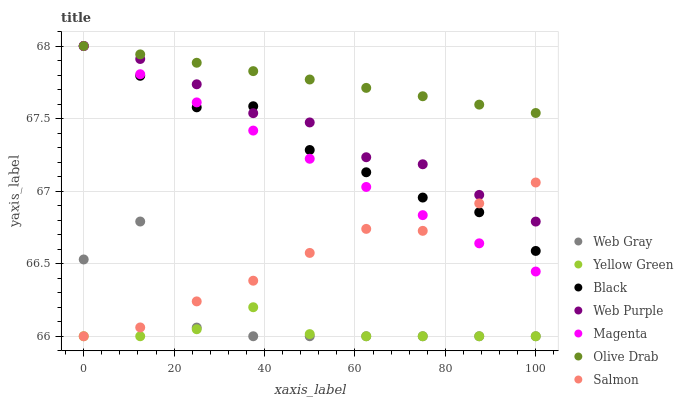Does Yellow Green have the minimum area under the curve?
Answer yes or no. Yes. Does Olive Drab have the maximum area under the curve?
Answer yes or no. Yes. Does Salmon have the minimum area under the curve?
Answer yes or no. No. Does Salmon have the maximum area under the curve?
Answer yes or no. No. Is Olive Drab the smoothest?
Answer yes or no. Yes. Is Web Gray the roughest?
Answer yes or no. Yes. Is Yellow Green the smoothest?
Answer yes or no. No. Is Yellow Green the roughest?
Answer yes or no. No. Does Web Gray have the lowest value?
Answer yes or no. Yes. Does Web Purple have the lowest value?
Answer yes or no. No. Does Olive Drab have the highest value?
Answer yes or no. Yes. Does Salmon have the highest value?
Answer yes or no. No. Is Yellow Green less than Black?
Answer yes or no. Yes. Is Olive Drab greater than Web Gray?
Answer yes or no. Yes. Does Olive Drab intersect Black?
Answer yes or no. Yes. Is Olive Drab less than Black?
Answer yes or no. No. Is Olive Drab greater than Black?
Answer yes or no. No. Does Yellow Green intersect Black?
Answer yes or no. No. 